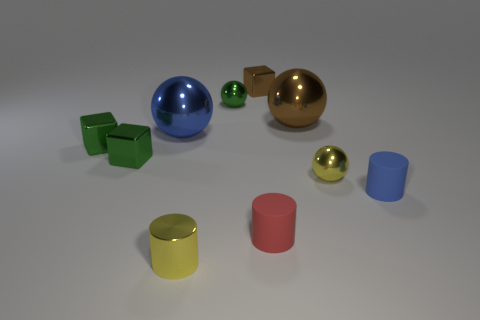Can you describe the sizes of the objects in relation to each other? Certainly! There are various objects of different sizes. The green cubes are smaller than the blue spheres, while the spherical objects vary with the gold one being the largest, the blue one of medium size, and the smallest spheres are the green and the gold. The cylinders present a range of sizes as well, with the yellow one being the tallest and the pink one the shortest. 